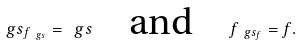Convert formula to latex. <formula><loc_0><loc_0><loc_500><loc_500>\ g s _ { f _ { \ g s } } = \ g s \quad \text {and} \quad f _ { \ g s _ { f } } = f .</formula> 